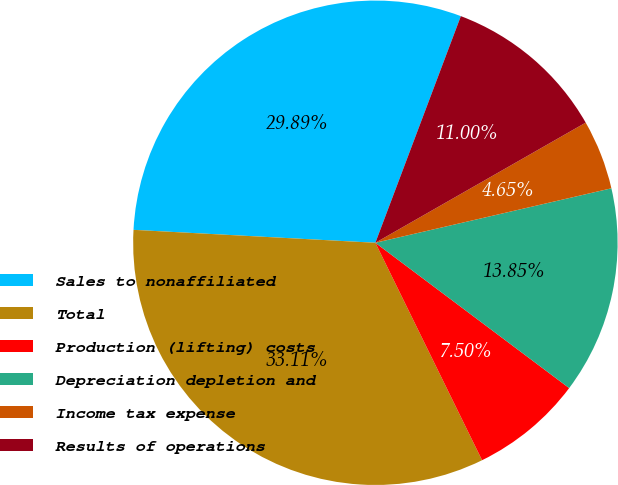<chart> <loc_0><loc_0><loc_500><loc_500><pie_chart><fcel>Sales to nonaffiliated<fcel>Total<fcel>Production (lifting) costs<fcel>Depreciation depletion and<fcel>Income tax expense<fcel>Results of operations<nl><fcel>29.89%<fcel>33.11%<fcel>7.5%<fcel>13.85%<fcel>4.65%<fcel>11.0%<nl></chart> 